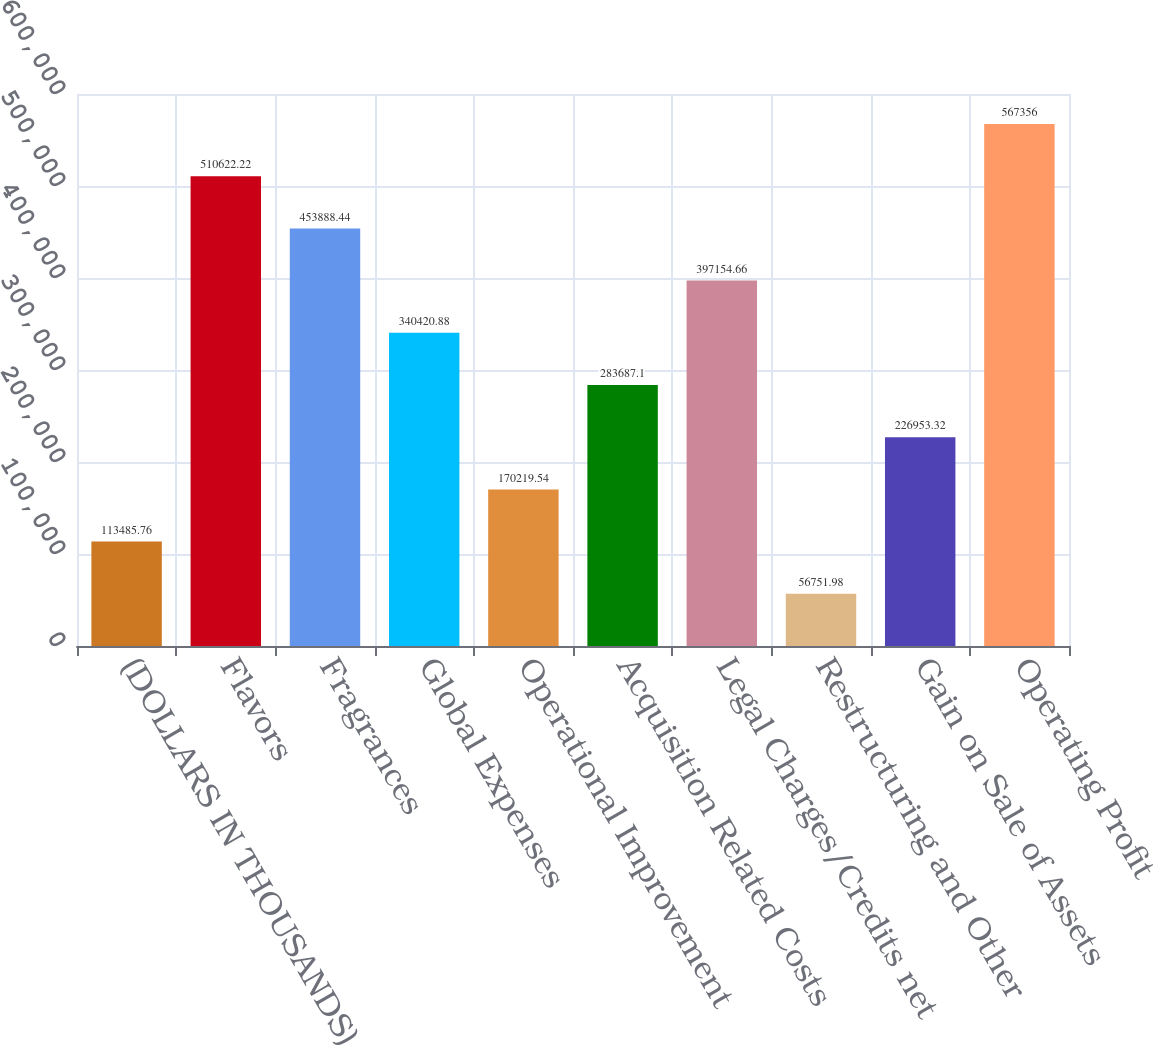Convert chart to OTSL. <chart><loc_0><loc_0><loc_500><loc_500><bar_chart><fcel>(DOLLARS IN THOUSANDS)<fcel>Flavors<fcel>Fragrances<fcel>Global Expenses<fcel>Operational Improvement<fcel>Acquisition Related Costs<fcel>Legal Charges/Credits net<fcel>Restructuring and Other<fcel>Gain on Sale of Assets<fcel>Operating Profit<nl><fcel>113486<fcel>510622<fcel>453888<fcel>340421<fcel>170220<fcel>283687<fcel>397155<fcel>56752<fcel>226953<fcel>567356<nl></chart> 